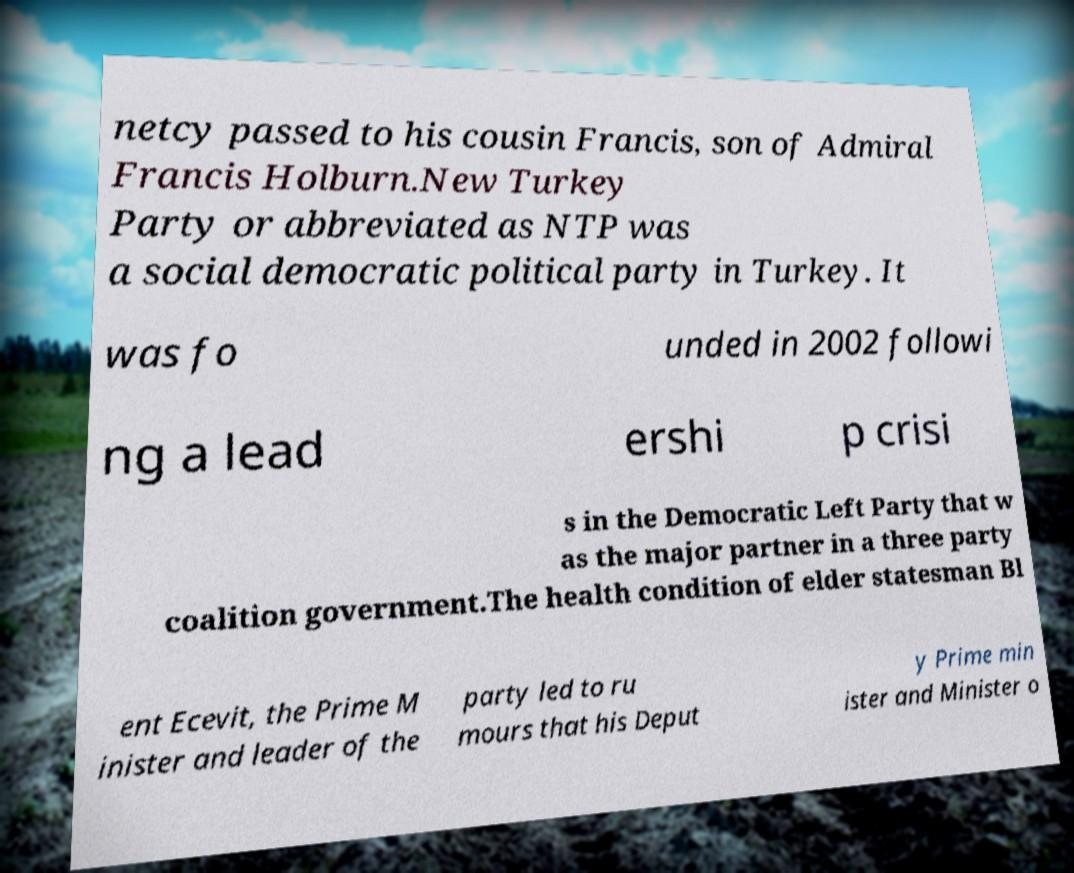Can you accurately transcribe the text from the provided image for me? netcy passed to his cousin Francis, son of Admiral Francis Holburn.New Turkey Party or abbreviated as NTP was a social democratic political party in Turkey. It was fo unded in 2002 followi ng a lead ershi p crisi s in the Democratic Left Party that w as the major partner in a three party coalition government.The health condition of elder statesman Bl ent Ecevit, the Prime M inister and leader of the party led to ru mours that his Deput y Prime min ister and Minister o 